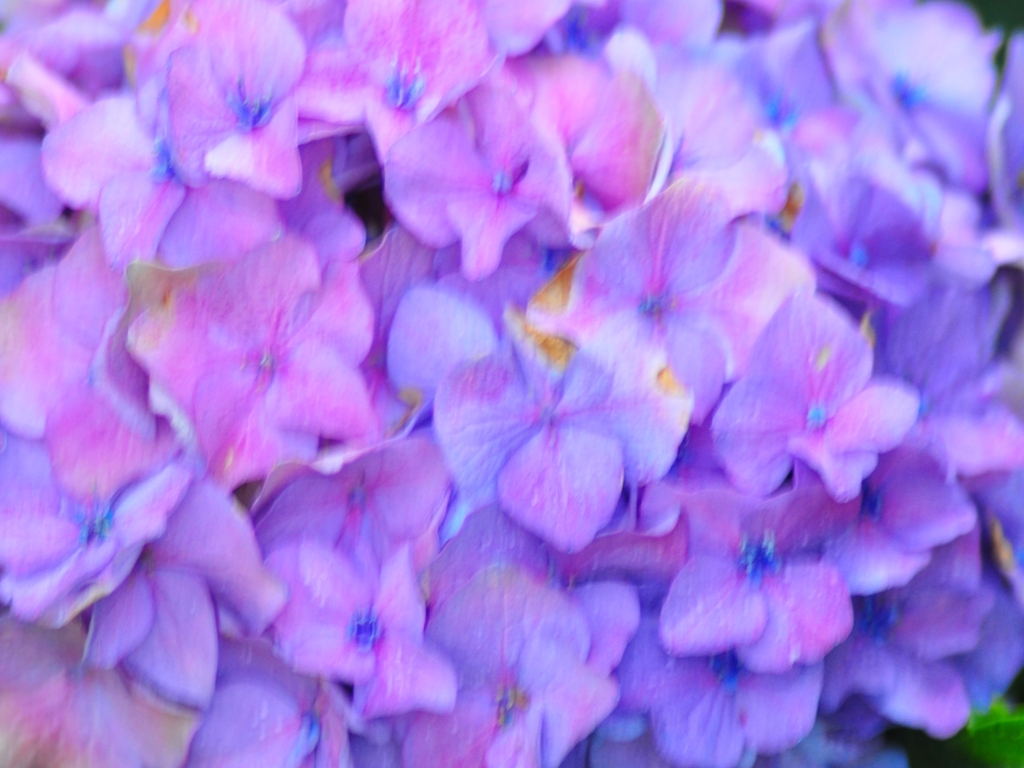Does the picture have vibrant color contrast?
A. Yes
B. No
Answer with the option's letter from the given choices directly.
 A. 